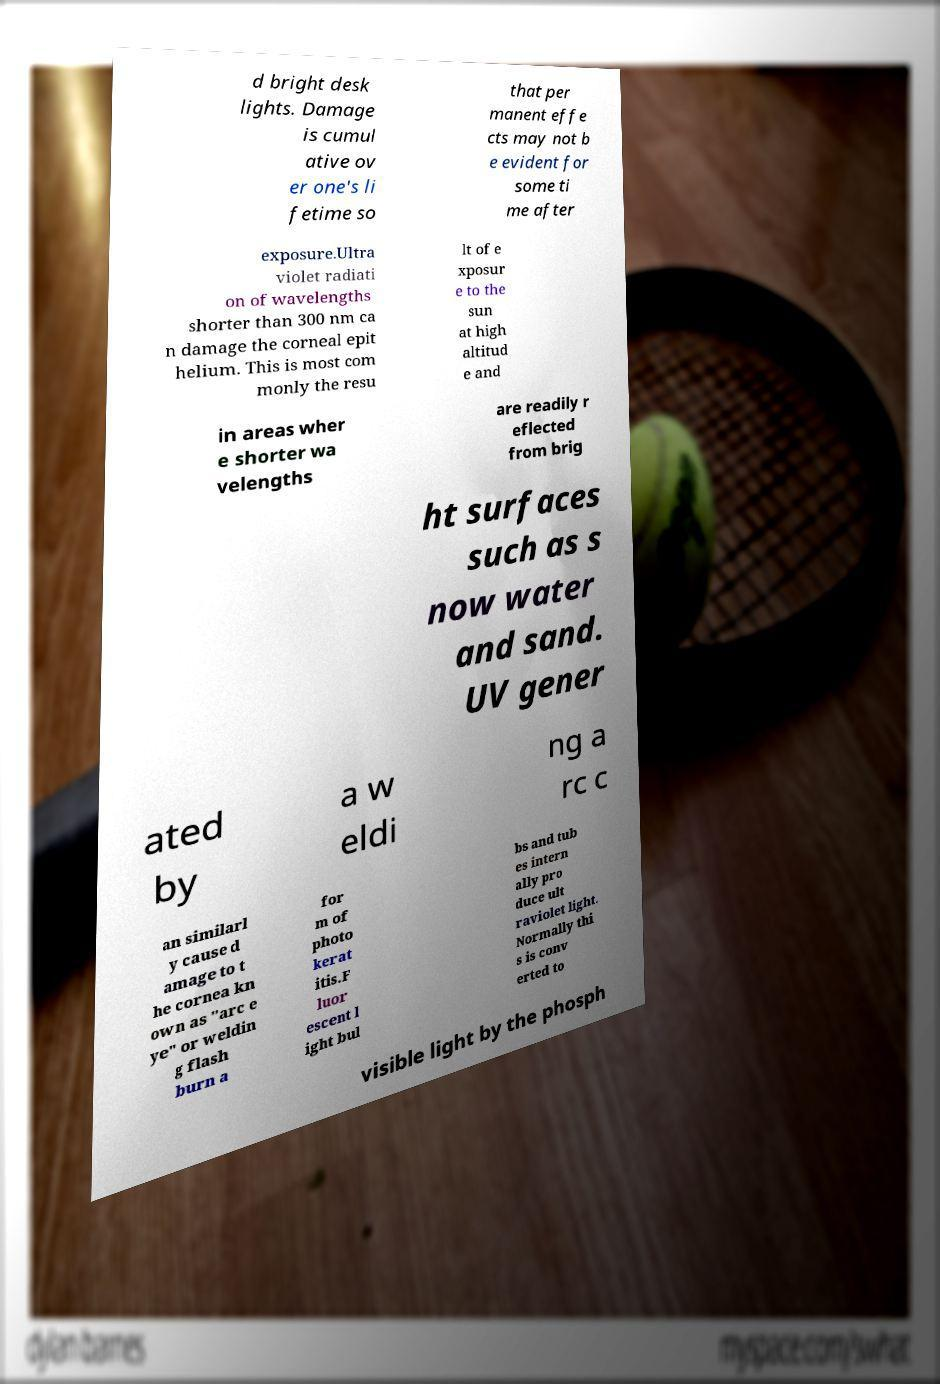Please identify and transcribe the text found in this image. d bright desk lights. Damage is cumul ative ov er one's li fetime so that per manent effe cts may not b e evident for some ti me after exposure.Ultra violet radiati on of wavelengths shorter than 300 nm ca n damage the corneal epit helium. This is most com monly the resu lt of e xposur e to the sun at high altitud e and in areas wher e shorter wa velengths are readily r eflected from brig ht surfaces such as s now water and sand. UV gener ated by a w eldi ng a rc c an similarl y cause d amage to t he cornea kn own as "arc e ye" or weldin g flash burn a for m of photo kerat itis.F luor escent l ight bul bs and tub es intern ally pro duce ult raviolet light. Normally thi s is conv erted to visible light by the phosph 